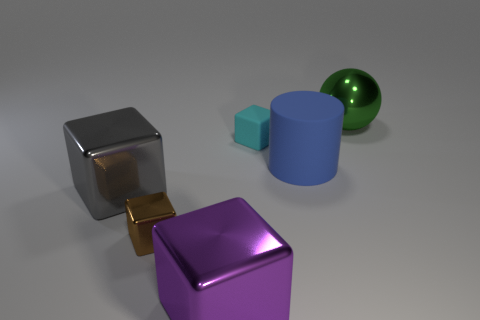What number of other spheres have the same color as the big sphere?
Make the answer very short. 0. The matte thing that is the same shape as the small metallic object is what color?
Ensure brevity in your answer.  Cyan. The large object that is behind the big gray metallic thing and in front of the green object has what shape?
Make the answer very short. Cylinder. Is the number of small yellow cylinders greater than the number of cylinders?
Provide a short and direct response. No. What material is the purple block?
Offer a very short reply. Metal. Is there anything else that is the same size as the matte cylinder?
Your response must be concise. Yes. The cyan rubber object that is the same shape as the tiny shiny object is what size?
Keep it short and to the point. Small. Are there any purple shiny things in front of the tiny block in front of the large blue rubber cylinder?
Give a very brief answer. Yes. Do the large metallic ball and the tiny rubber cube have the same color?
Your response must be concise. No. What number of other things are there of the same shape as the big gray thing?
Make the answer very short. 3. 